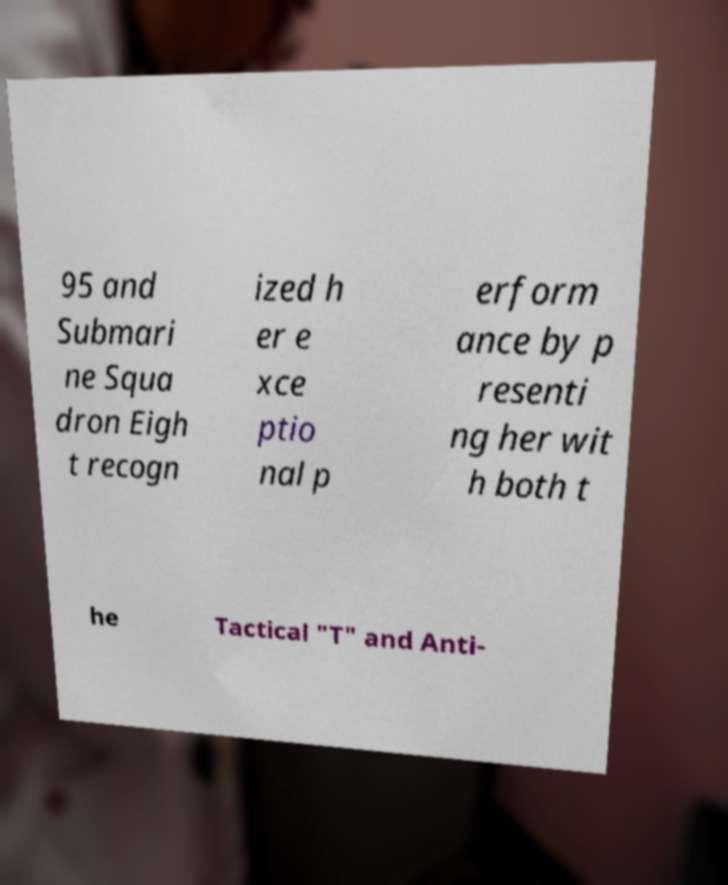Can you accurately transcribe the text from the provided image for me? 95 and Submari ne Squa dron Eigh t recogn ized h er e xce ptio nal p erform ance by p resenti ng her wit h both t he Tactical "T" and Anti- 